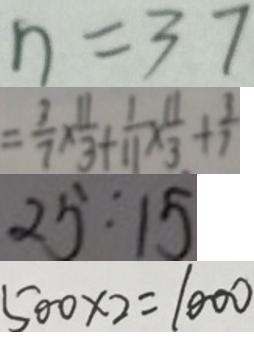Convert formula to latex. <formula><loc_0><loc_0><loc_500><loc_500>n = 3 7 
 = \frac { 3 } { 7 } \times \frac { 1 1 } { 3 } + \frac { 1 } { 1 1 } \times \frac { 1 1 } { 3 } + \frac { 3 } { 7 } 
 2 5 : 1 5 
 5 0 0 \times 2 = 1 0 0 0</formula> 